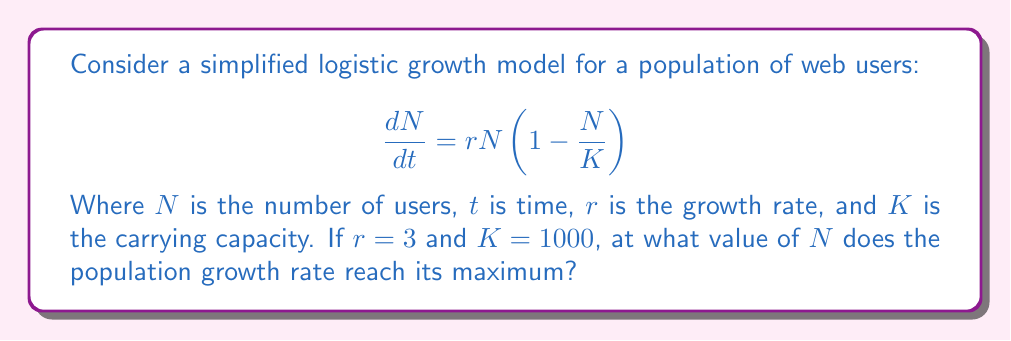Show me your answer to this math problem. To solve this problem, we'll approach it step-by-step:

1) First, let's expand the equation:
   $$\frac{dN}{dt} = rN - r\frac{N^2}{K}$$

2) With the given values, we have:
   $$\frac{dN}{dt} = 3N - 3\frac{N^2}{1000}$$

3) To find the maximum growth rate, we need to find the derivative of this function with respect to $N$ and set it to zero:
   $$\frac{d}{dN}(\frac{dN}{dt}) = 3 - 3\frac{2N}{1000} = 0$$

4) Simplify:
   $$3 - \frac{6N}{1000} = 0$$

5) Solve for $N$:
   $$\frac{6N}{1000} = 3$$
   $$6N = 3000$$
   $$N = 500$$

6) This result can be interpreted in terms of web development: the user base grows fastest when it's at half the carrying capacity, which is a common characteristic of logistic growth models.
Answer: $N = 500$ 